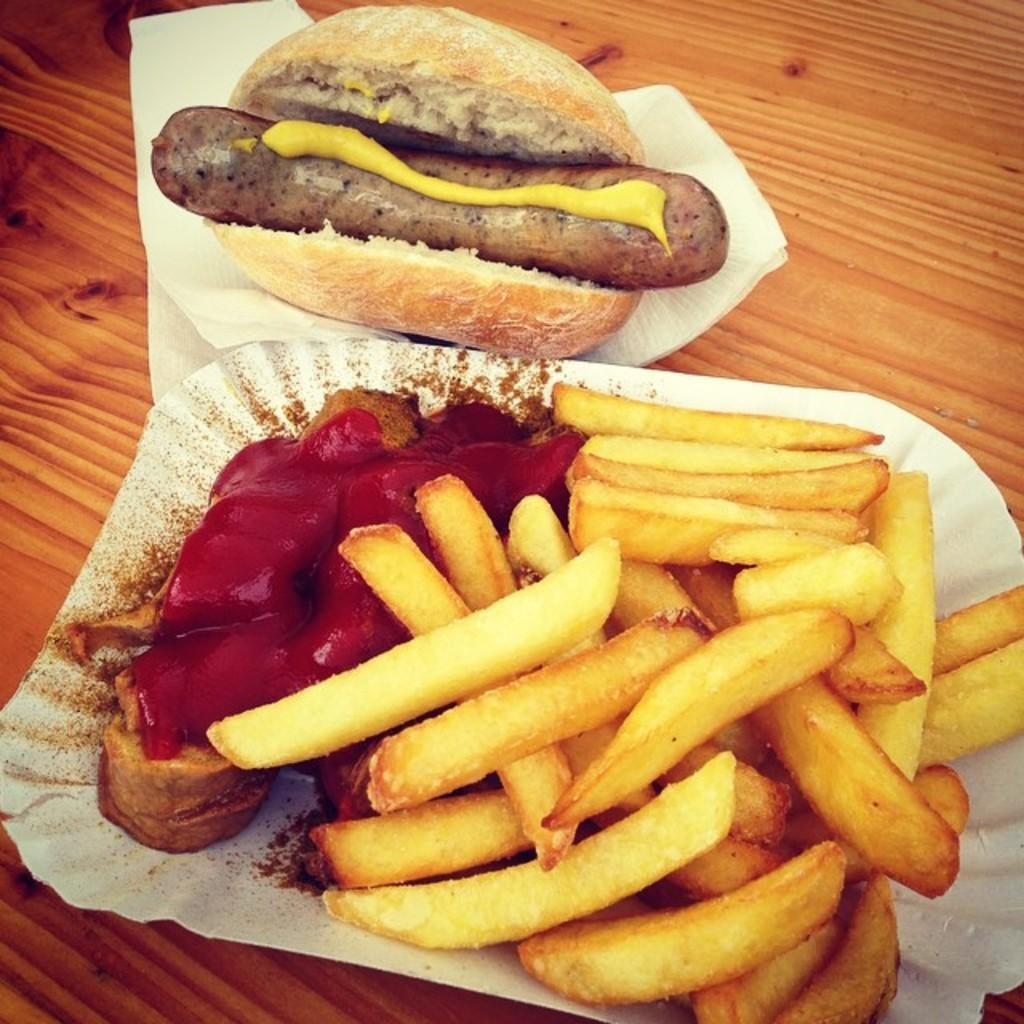What types of items can be seen in the image? There are food items and papers in the image. Can you describe one of the food items? Yes, there is a sausage in the image. Where are the papers located in the image? The papers are on a wooden item. What type of vest is being worn by the sausage in the image? There is no vest present in the image, and the sausage is not a living being that can wear clothing. 